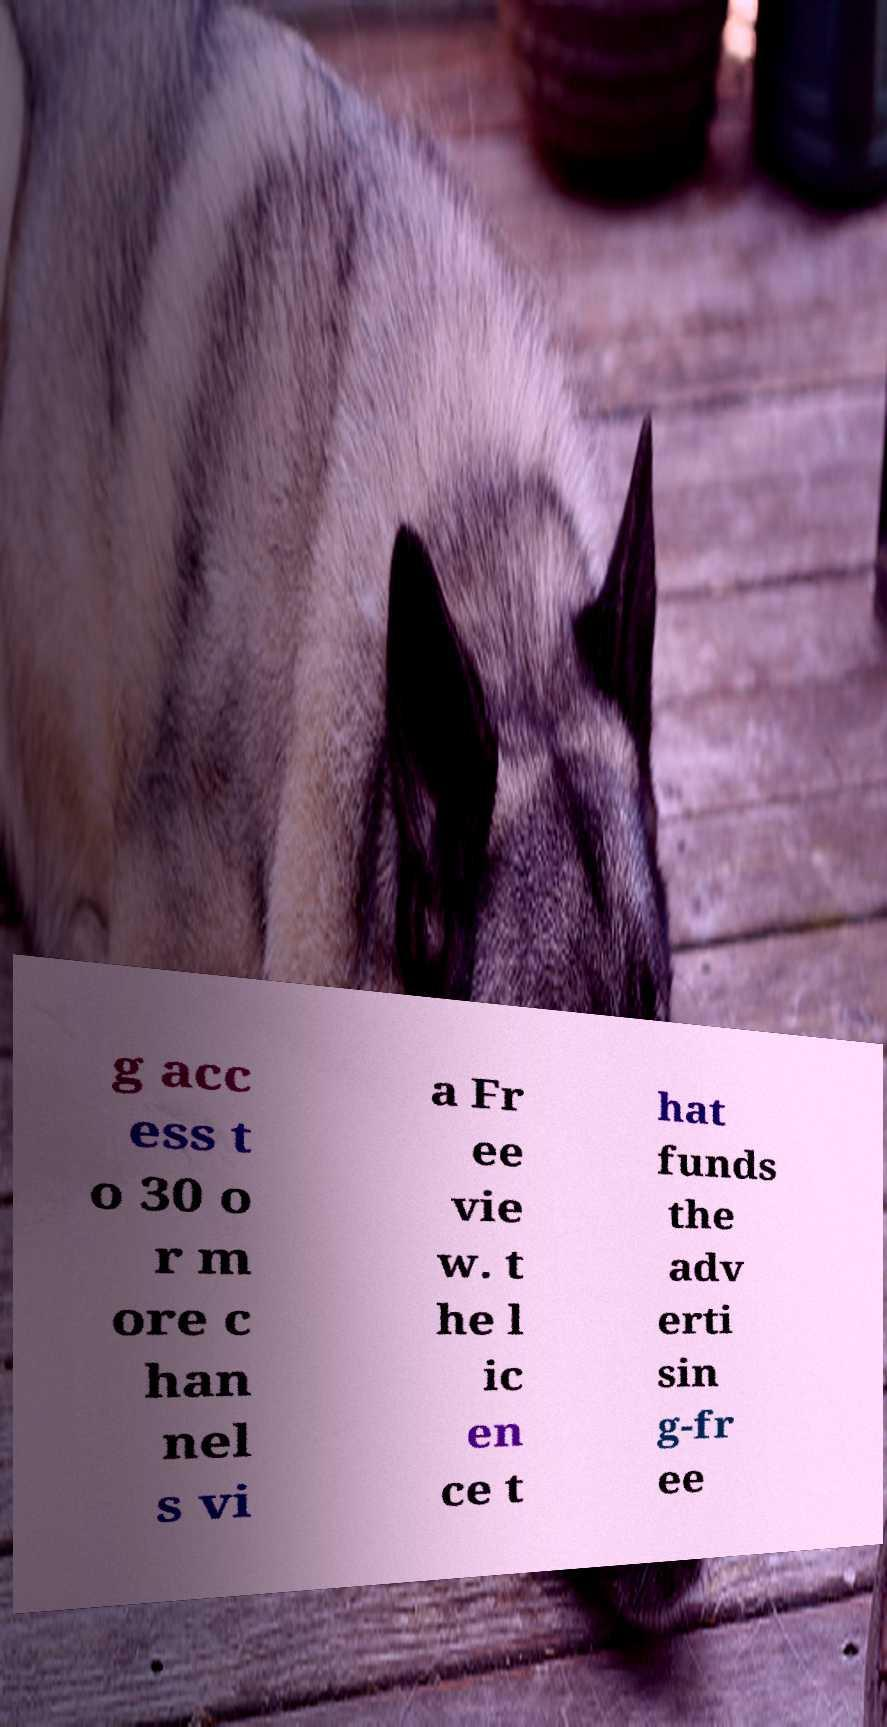Please identify and transcribe the text found in this image. g acc ess t o 30 o r m ore c han nel s vi a Fr ee vie w. t he l ic en ce t hat funds the adv erti sin g-fr ee 